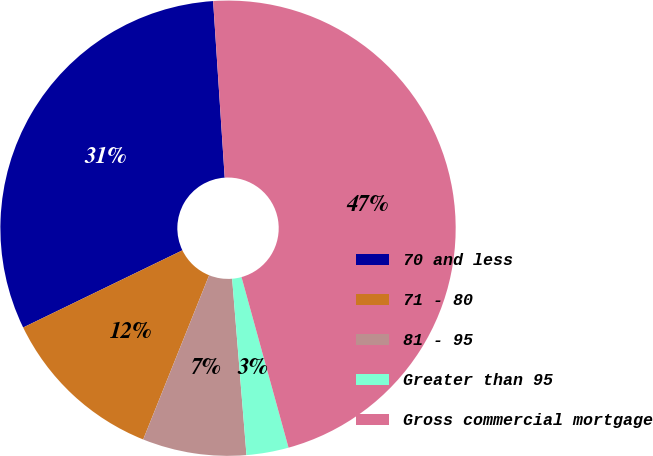<chart> <loc_0><loc_0><loc_500><loc_500><pie_chart><fcel>70 and less<fcel>71 - 80<fcel>81 - 95<fcel>Greater than 95<fcel>Gross commercial mortgage<nl><fcel>31.14%<fcel>11.74%<fcel>7.37%<fcel>2.99%<fcel>46.76%<nl></chart> 